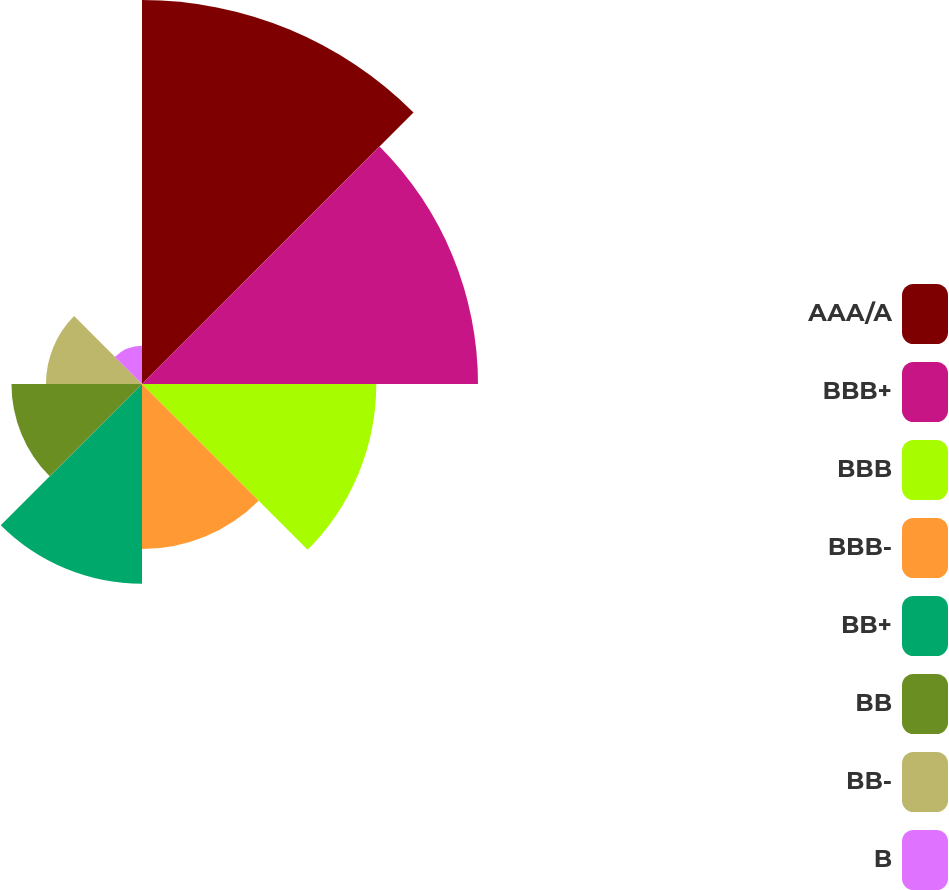Convert chart to OTSL. <chart><loc_0><loc_0><loc_500><loc_500><pie_chart><fcel>AAA/A<fcel>BBB+<fcel>BBB<fcel>BBB-<fcel>BB+<fcel>BB<fcel>BB-<fcel>B<nl><fcel>24.24%<fcel>21.21%<fcel>14.79%<fcel>10.42%<fcel>12.61%<fcel>8.24%<fcel>6.06%<fcel>2.42%<nl></chart> 